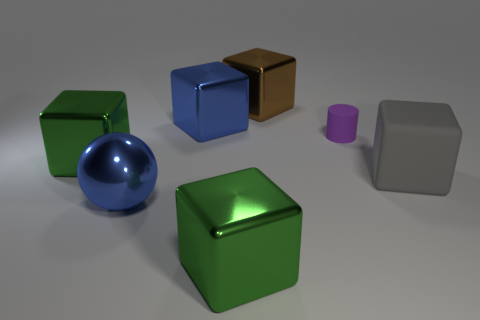There is a metallic thing that is the same color as the ball; what is its shape?
Give a very brief answer. Cube. Does the block that is behind the blue metallic cube have the same color as the large sphere?
Offer a terse response. No. Is the shape of the green object in front of the gray object the same as the big blue thing to the right of the big blue ball?
Your answer should be compact. Yes. What size is the blue object in front of the small purple thing?
Your response must be concise. Large. There is a green cube that is behind the big cube that is right of the brown metal block; what size is it?
Your answer should be very brief. Large. Are there more small green matte blocks than gray matte things?
Ensure brevity in your answer.  No. Are there more large objects that are to the right of the large rubber cube than large rubber objects to the left of the blue ball?
Offer a very short reply. No. How big is the thing that is to the right of the big brown cube and in front of the small thing?
Your answer should be compact. Large. What number of brown metallic objects are the same size as the purple object?
Give a very brief answer. 0. What is the material of the big object that is the same color as the metallic ball?
Ensure brevity in your answer.  Metal. 